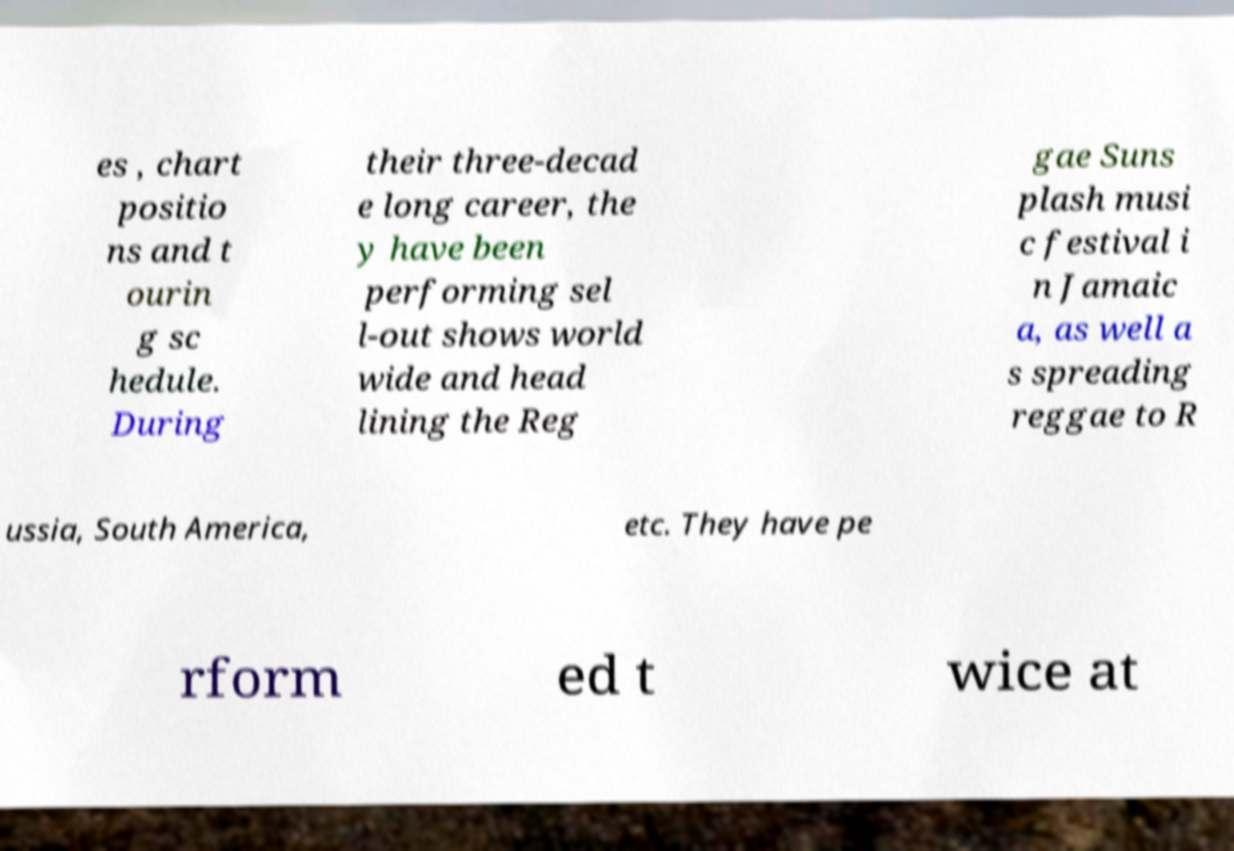Please identify and transcribe the text found in this image. es , chart positio ns and t ourin g sc hedule. During their three-decad e long career, the y have been performing sel l-out shows world wide and head lining the Reg gae Suns plash musi c festival i n Jamaic a, as well a s spreading reggae to R ussia, South America, etc. They have pe rform ed t wice at 